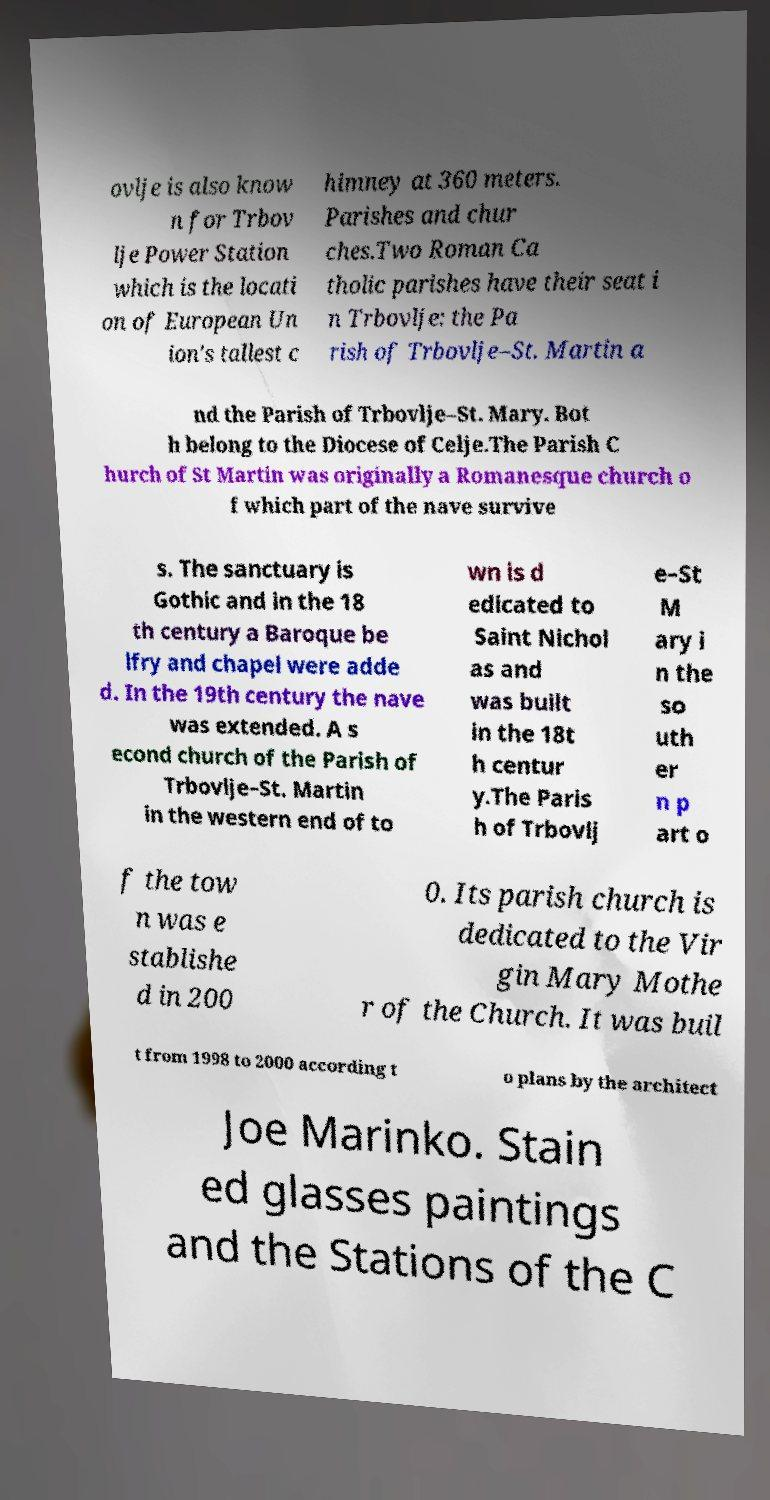What messages or text are displayed in this image? I need them in a readable, typed format. ovlje is also know n for Trbov lje Power Station which is the locati on of European Un ion's tallest c himney at 360 meters. Parishes and chur ches.Two Roman Ca tholic parishes have their seat i n Trbovlje: the Pa rish of Trbovlje–St. Martin a nd the Parish of Trbovlje–St. Mary. Bot h belong to the Diocese of Celje.The Parish C hurch of St Martin was originally a Romanesque church o f which part of the nave survive s. The sanctuary is Gothic and in the 18 th century a Baroque be lfry and chapel were adde d. In the 19th century the nave was extended. A s econd church of the Parish of Trbovlje–St. Martin in the western end of to wn is d edicated to Saint Nichol as and was built in the 18t h centur y.The Paris h of Trbovlj e–St M ary i n the so uth er n p art o f the tow n was e stablishe d in 200 0. Its parish church is dedicated to the Vir gin Mary Mothe r of the Church. It was buil t from 1998 to 2000 according t o plans by the architect Joe Marinko. Stain ed glasses paintings and the Stations of the C 